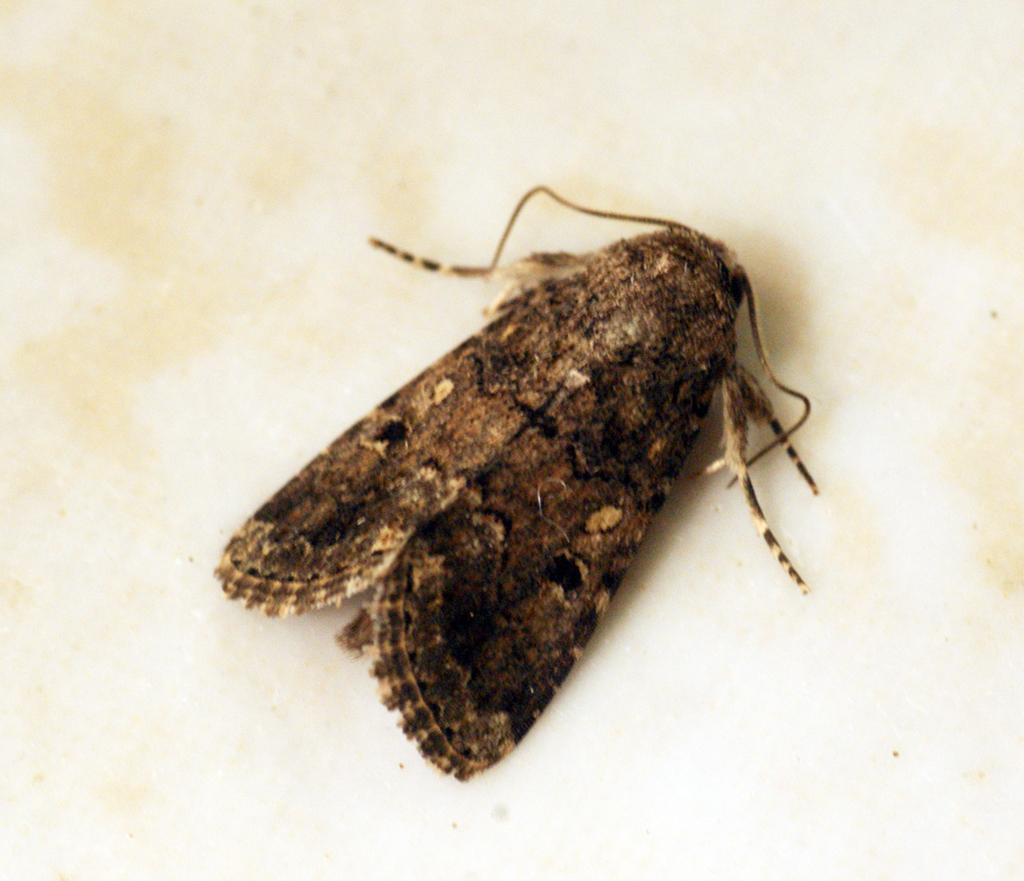What is the main subject of the image? There is a moth in the middle of the image. What can be seen in the background of the image? The background of the image is a plane. How many snakes are wrapped around the moth in the image? There are no snakes present in the image; it features a moth with a plain background. What type of feather can be seen attached to the moth's wings in the image? There is no feather attached to the moth's wings in the image; it is a simple moth with no additional features. 